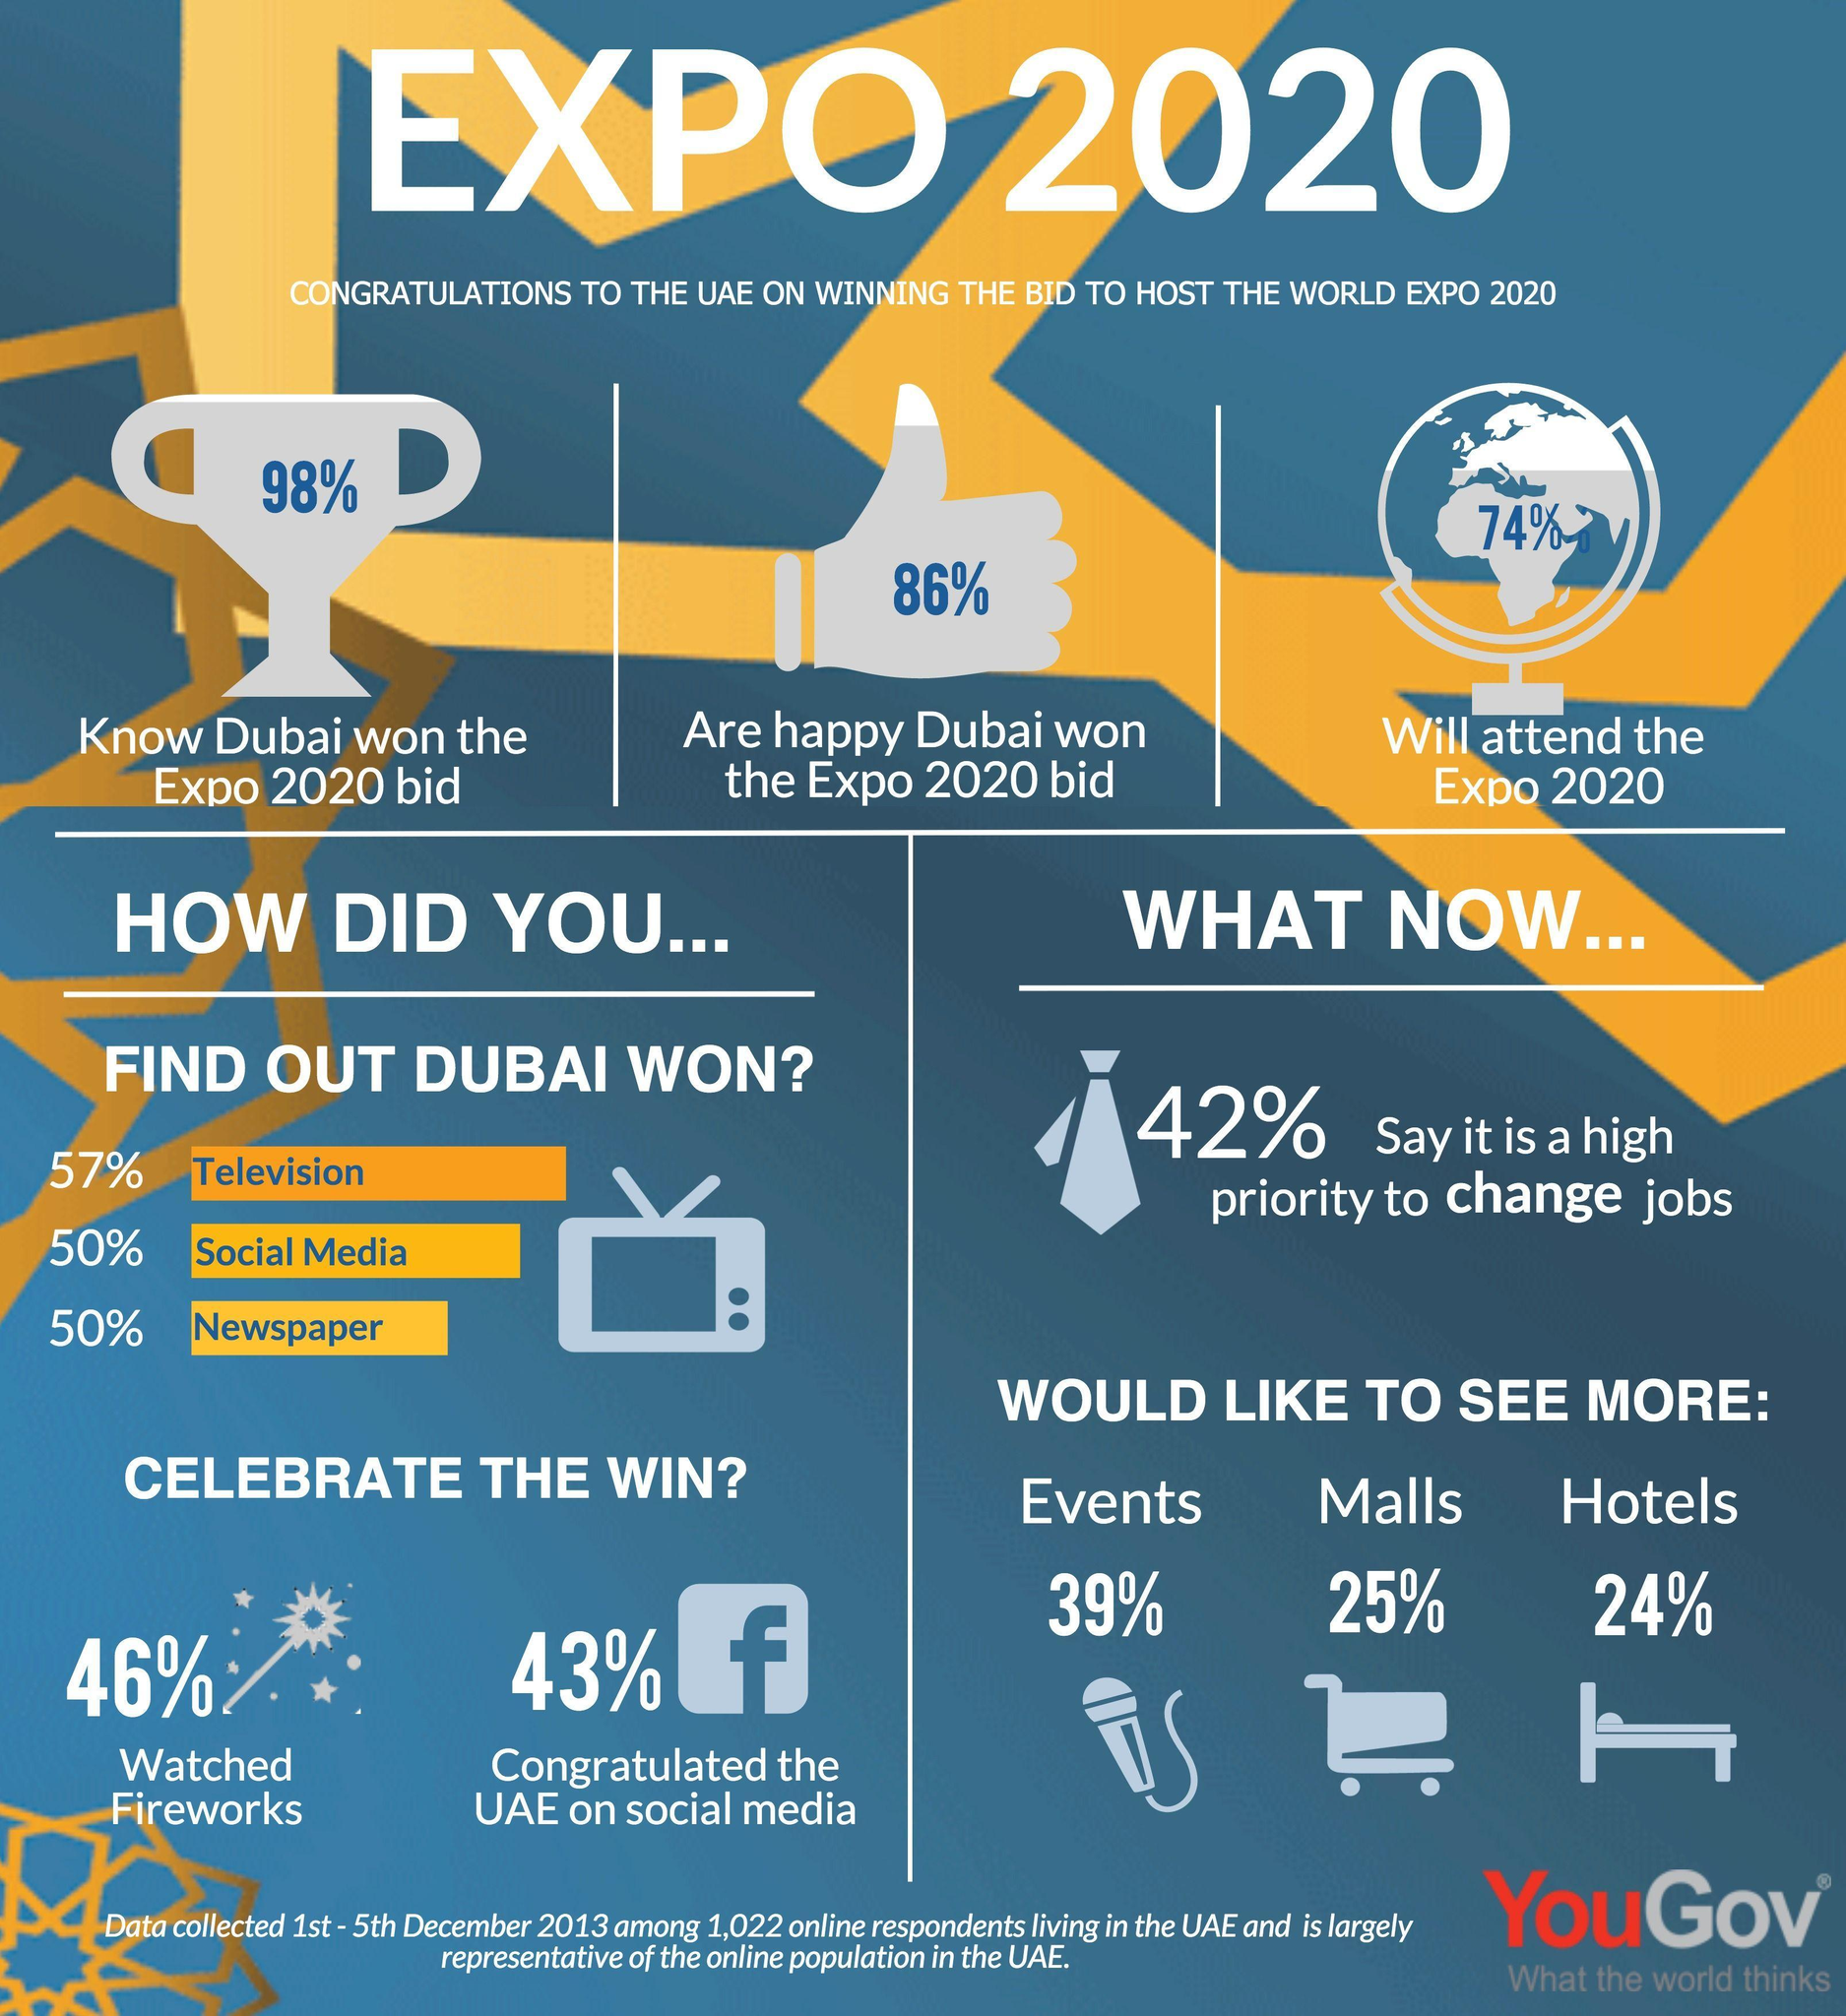How many of the people said they will attend the Expo 2020?
Answer the question with a short phrase. 74% How did 46% of the people celebrate the win? watched fireworks What percent of the people knew that Dubai won the Expo 2020 bid? 98% How did a larger number of people know about Dubai's win? television What percent of people congratulated UAE on social media? 43% How does 86% of the people feel about Dubai winning the bid? happy 